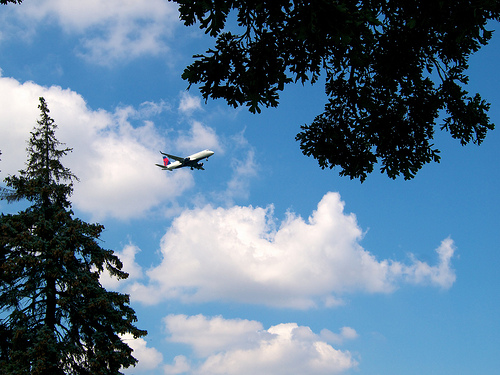Can you describe the setting in which this photo was taken? The photo appears to have been taken from a ground-level perspective in what looks like a park or natural outdoor area due to the presence of mature trees and clear skies. 